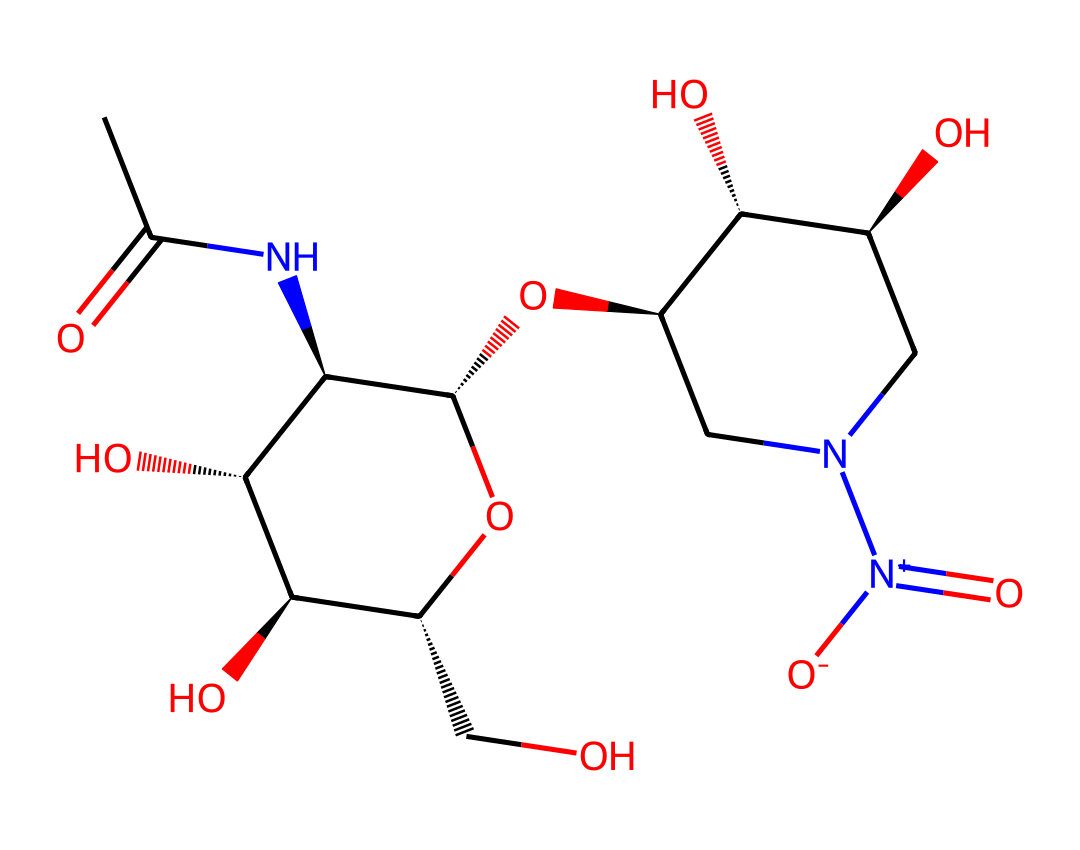What type of compound is tetrodotoxin? Tetrodotoxin is classified as a potent neurotoxin due to its biological activity and source organism (pufferfish).
Answer: neurotoxin How many nitrogen atoms are present in tetrodotoxin? By counting the nitrogen atoms represented in the SMILES notation, we find there are three nitrogen atoms.
Answer: three What functional groups are present in this chemical structure? The structure contains hydroxyl (OH), amino (NH), and nitro (NO2) functional groups, which suggest various biochemical properties.
Answer: hydroxyl, amino, nitro What is the molecular formula for tetrodotoxin based on its structure? Analyzing the structure's atoms leads to the conclusion that the molecular formula is C11H17N3O8.
Answer: C11H17N3O8 Which part of the tetrodotoxin structure is responsible for its toxic properties? The nitro group (NO2) enhances the toxicity of the compound by affecting ion channels in neurological functions.
Answer: nitro group Is tetrodotoxin soluble in water based on its structure? The presence of multiple hydroxyl groups suggests a high degree of polarity, indicating that tetrodotoxin is likely soluble in water.
Answer: yes 